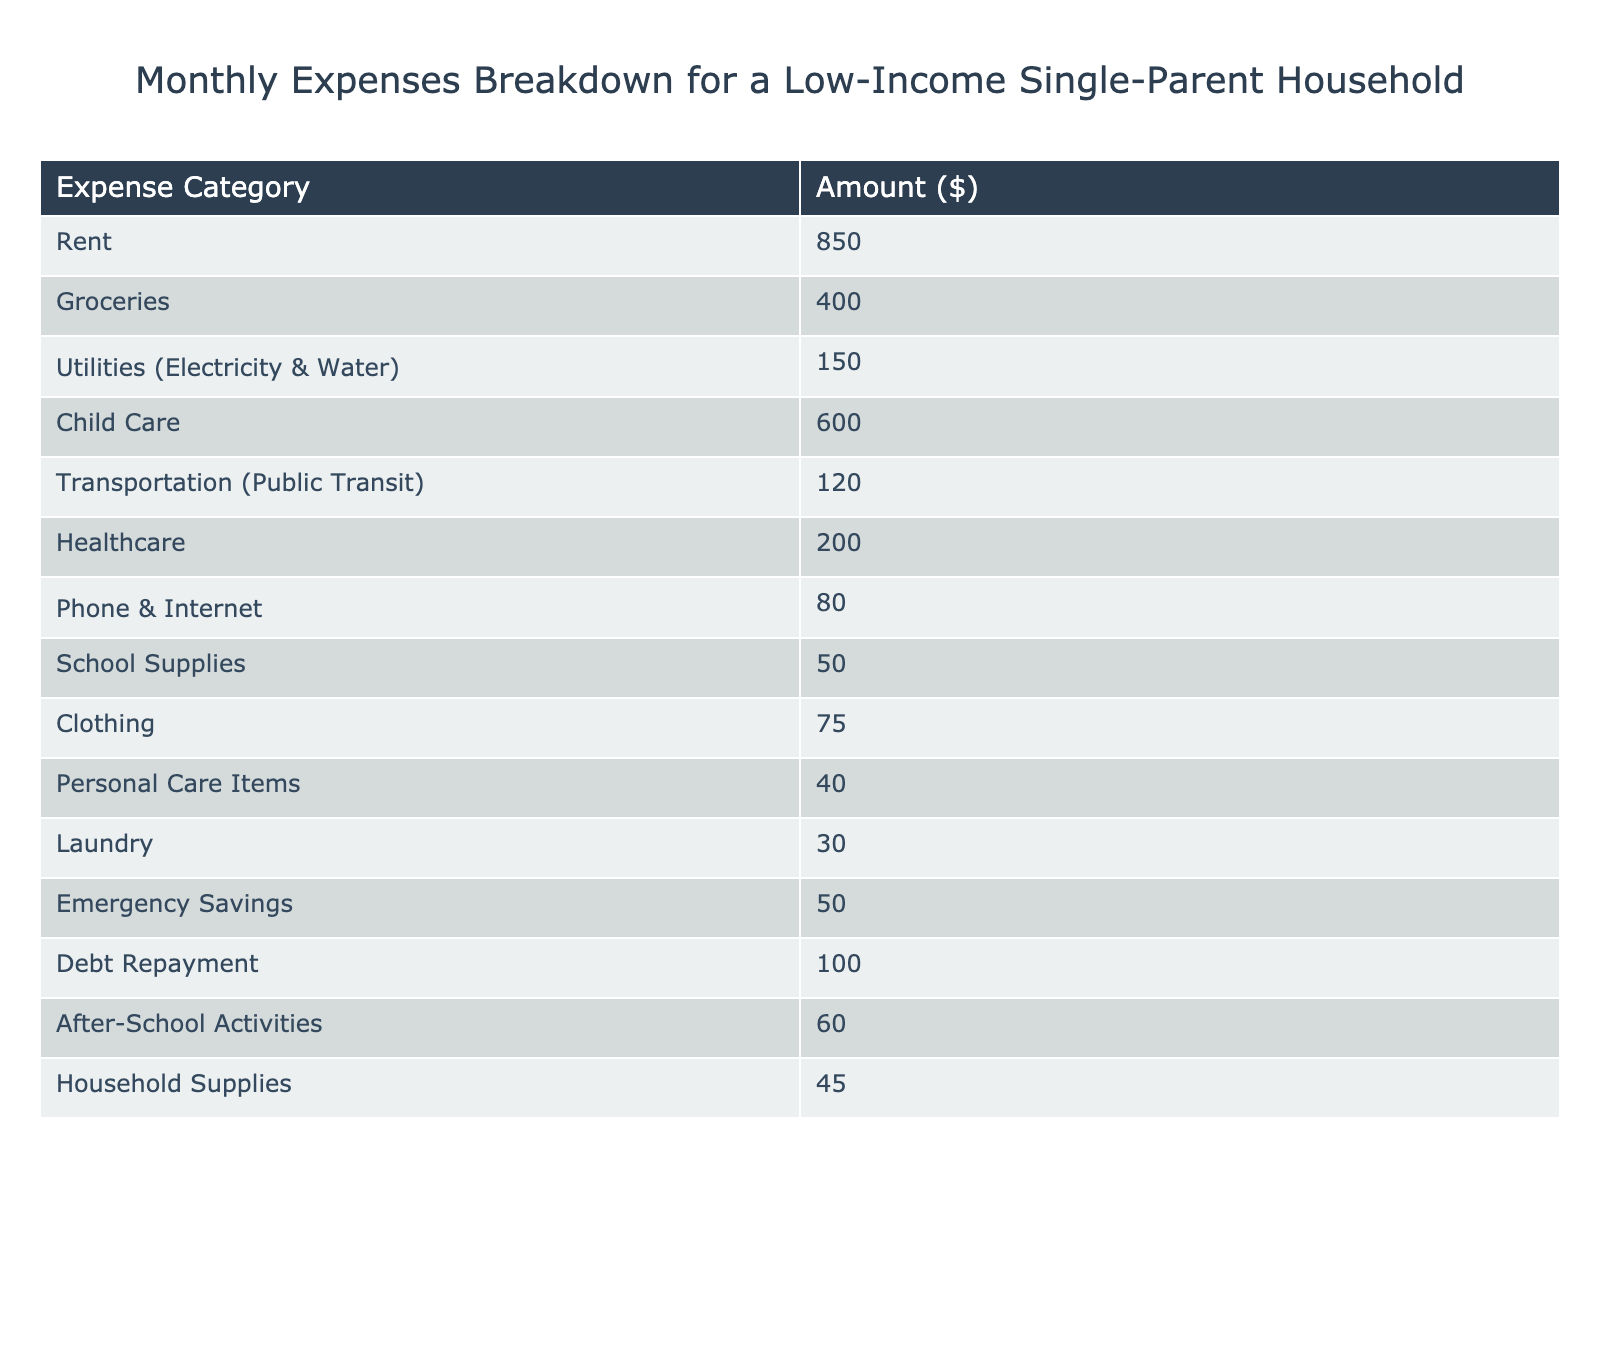What is the total amount spent on Child Care? The table shows that Child Care costs $600, which is a direct retrieval from the data presented.
Answer: 600 What are the monthly expenses for rent and utilities combined? The rent is $850 and utilities cost $150. Adding these amounts gives us $850 + $150 = $1000.
Answer: 1000 Is the expense on Groceries greater than on Clothing? The table indicates Groceries cost $400 and Clothing costs $75. Since $400 is greater than $75, the statement is true.
Answer: Yes What is the total monthly spending on transportation, personal care items, and laundry? The transportation expense is $120, personal care items are $40, and laundry is $30. Adding them gives $120 + $40 + $30 = $190.
Answer: 190 What is the percentage of total expenses spent on Healthcare? First, we calculate the total expenses: $850 + $400 + $150 + $600 + $120 + $200 + $80 + $50 + $75 + $40 + $30 + $50 + $100 + $60 + $45 = $2,655. Healthcare costs $200. To find the percentage, we use the formula (200/2655) * 100, which is approximately 7.53%.
Answer: 7.53% What is the difference between the highest and lowest monthly expense? The highest expense is Rent at $850, and the lowest is Laundry at $30. The difference is $850 - $30 = $820.
Answer: 820 If we add all the expenses related to children (Child Care and After-School Activities), what is the total? Child Care costs $600 and After-School Activities cost $60. Adding these amounts gives $600 + $60 = $660.
Answer: 660 Are the total expenses for Debt Repayment and Emergency Savings less than $200? Debt Repayment is $100 and Emergency Savings is $50. Their total is $100 + $50 = $150, which is less than $200. Thus, the statement is true.
Answer: Yes What is the average expense across all categories listed? The total expenses are $2,655, and there are 15 categories. To get the average, we divide the total by the number of categories: $2,655 / 15 = $177.
Answer: 177 What two categories have the most significant expense after Rent? After Rent, Child Care costs $600, making it the second highest expense, and expenses for Groceries are $400, which is the third. Thus, Child Care and Groceries are the two largest categories after Rent.
Answer: Child Care and Groceries 